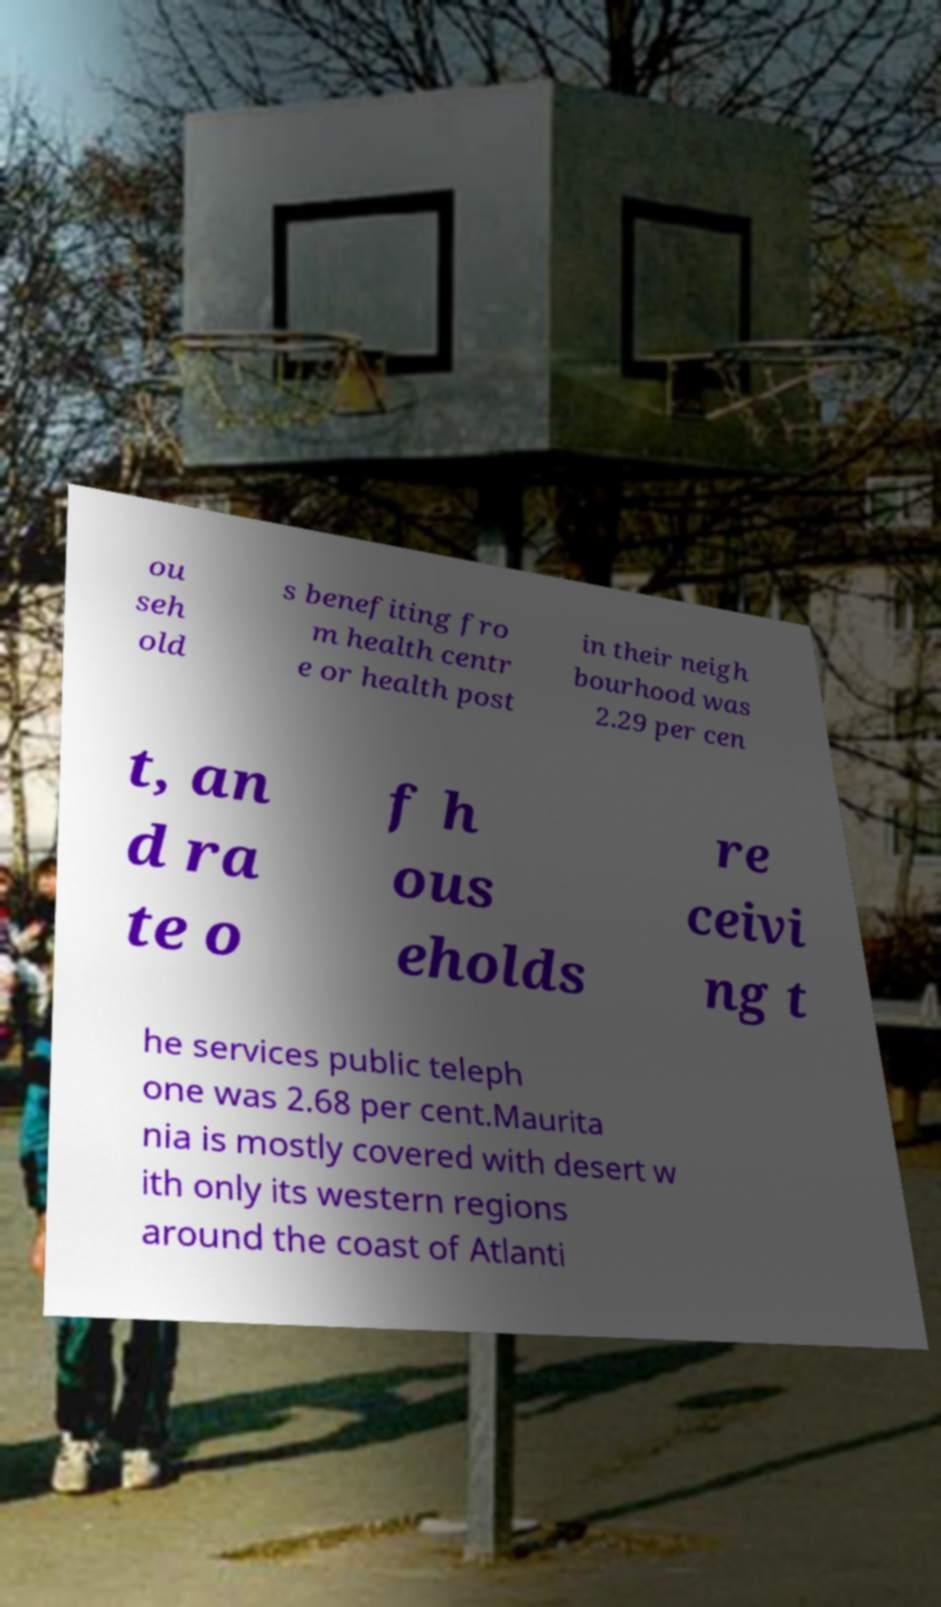Could you extract and type out the text from this image? ou seh old s benefiting fro m health centr e or health post in their neigh bourhood was 2.29 per cen t, an d ra te o f h ous eholds re ceivi ng t he services public teleph one was 2.68 per cent.Maurita nia is mostly covered with desert w ith only its western regions around the coast of Atlanti 